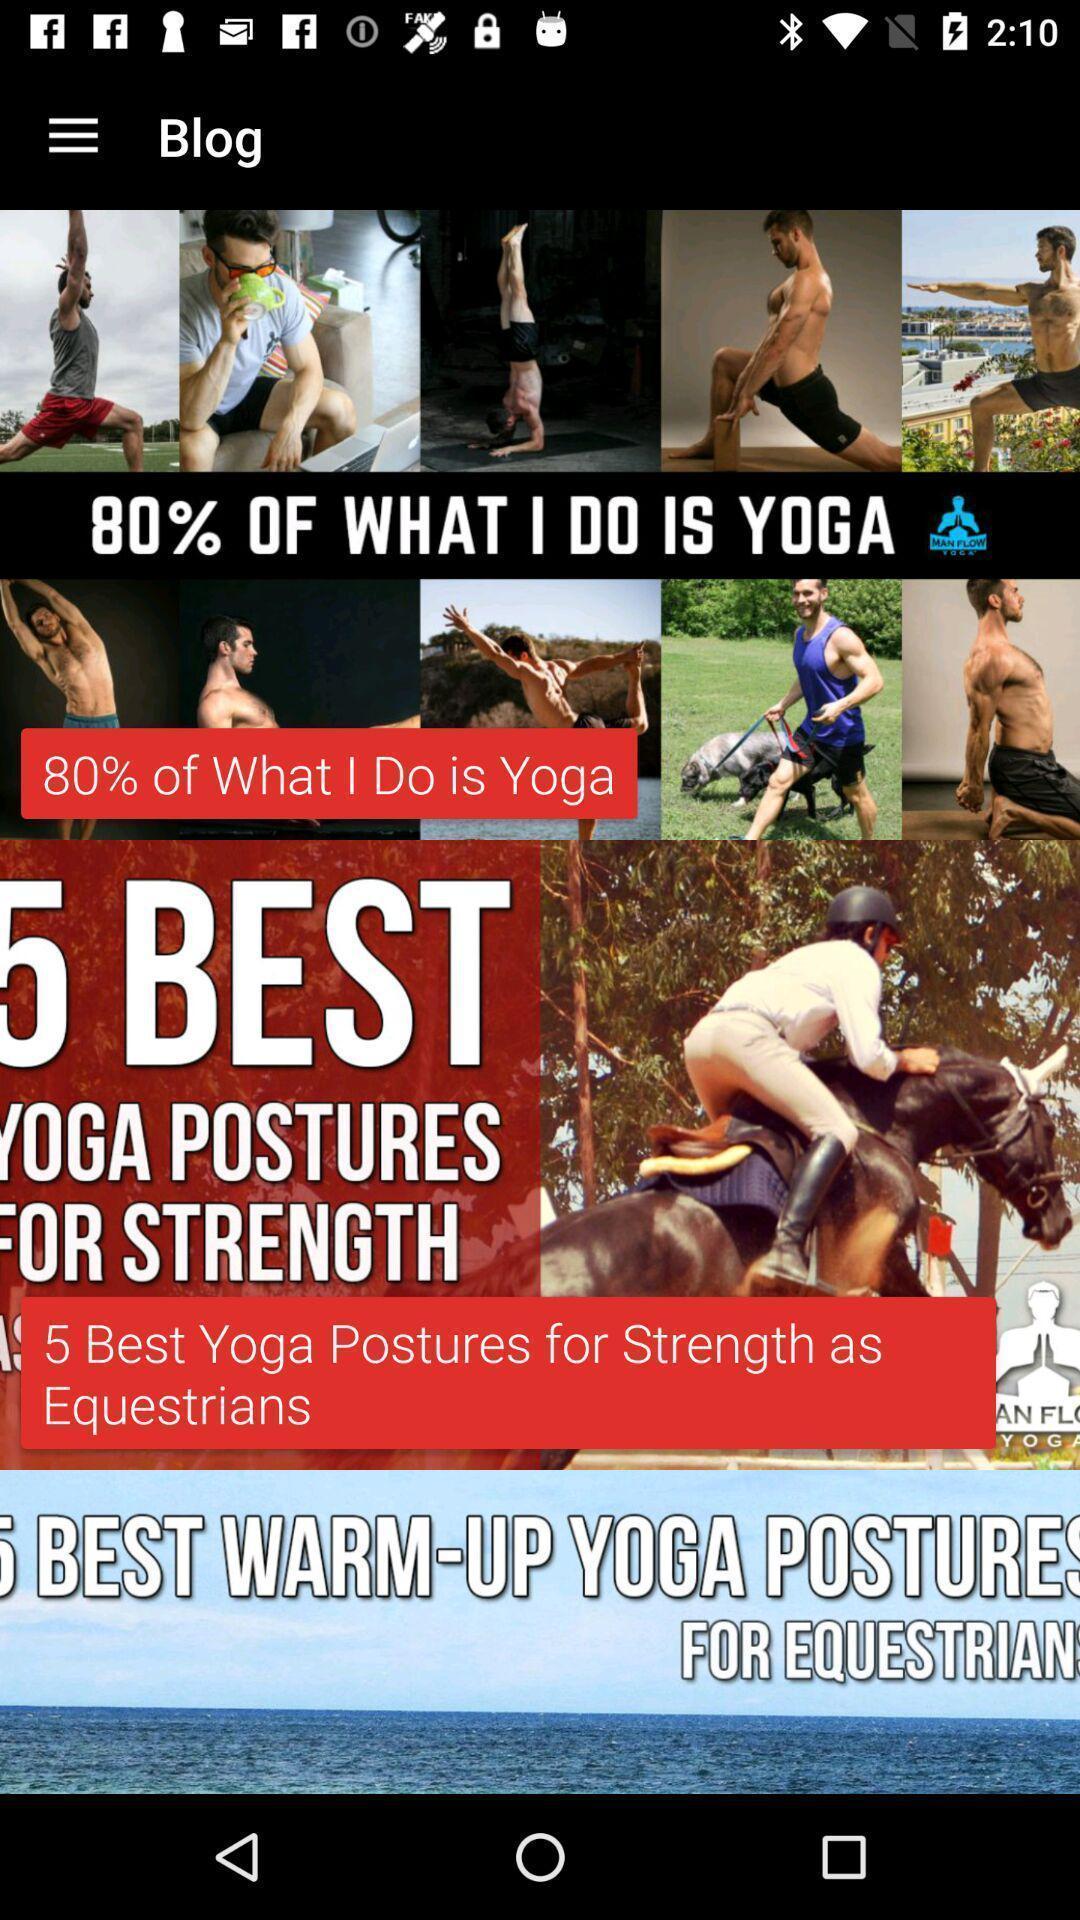Describe this image in words. Screen displaying blog about yoga. 